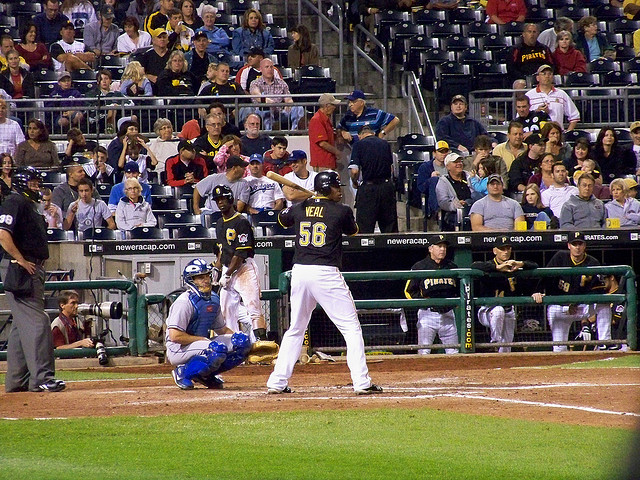<image>Is the batter right-handed? I don't know if the batter is right-handed. It can be either right or left-handed. Is the batter right-handed? I don't know if the batter is right-handed. It can be seen both left-handed and right-handed. 